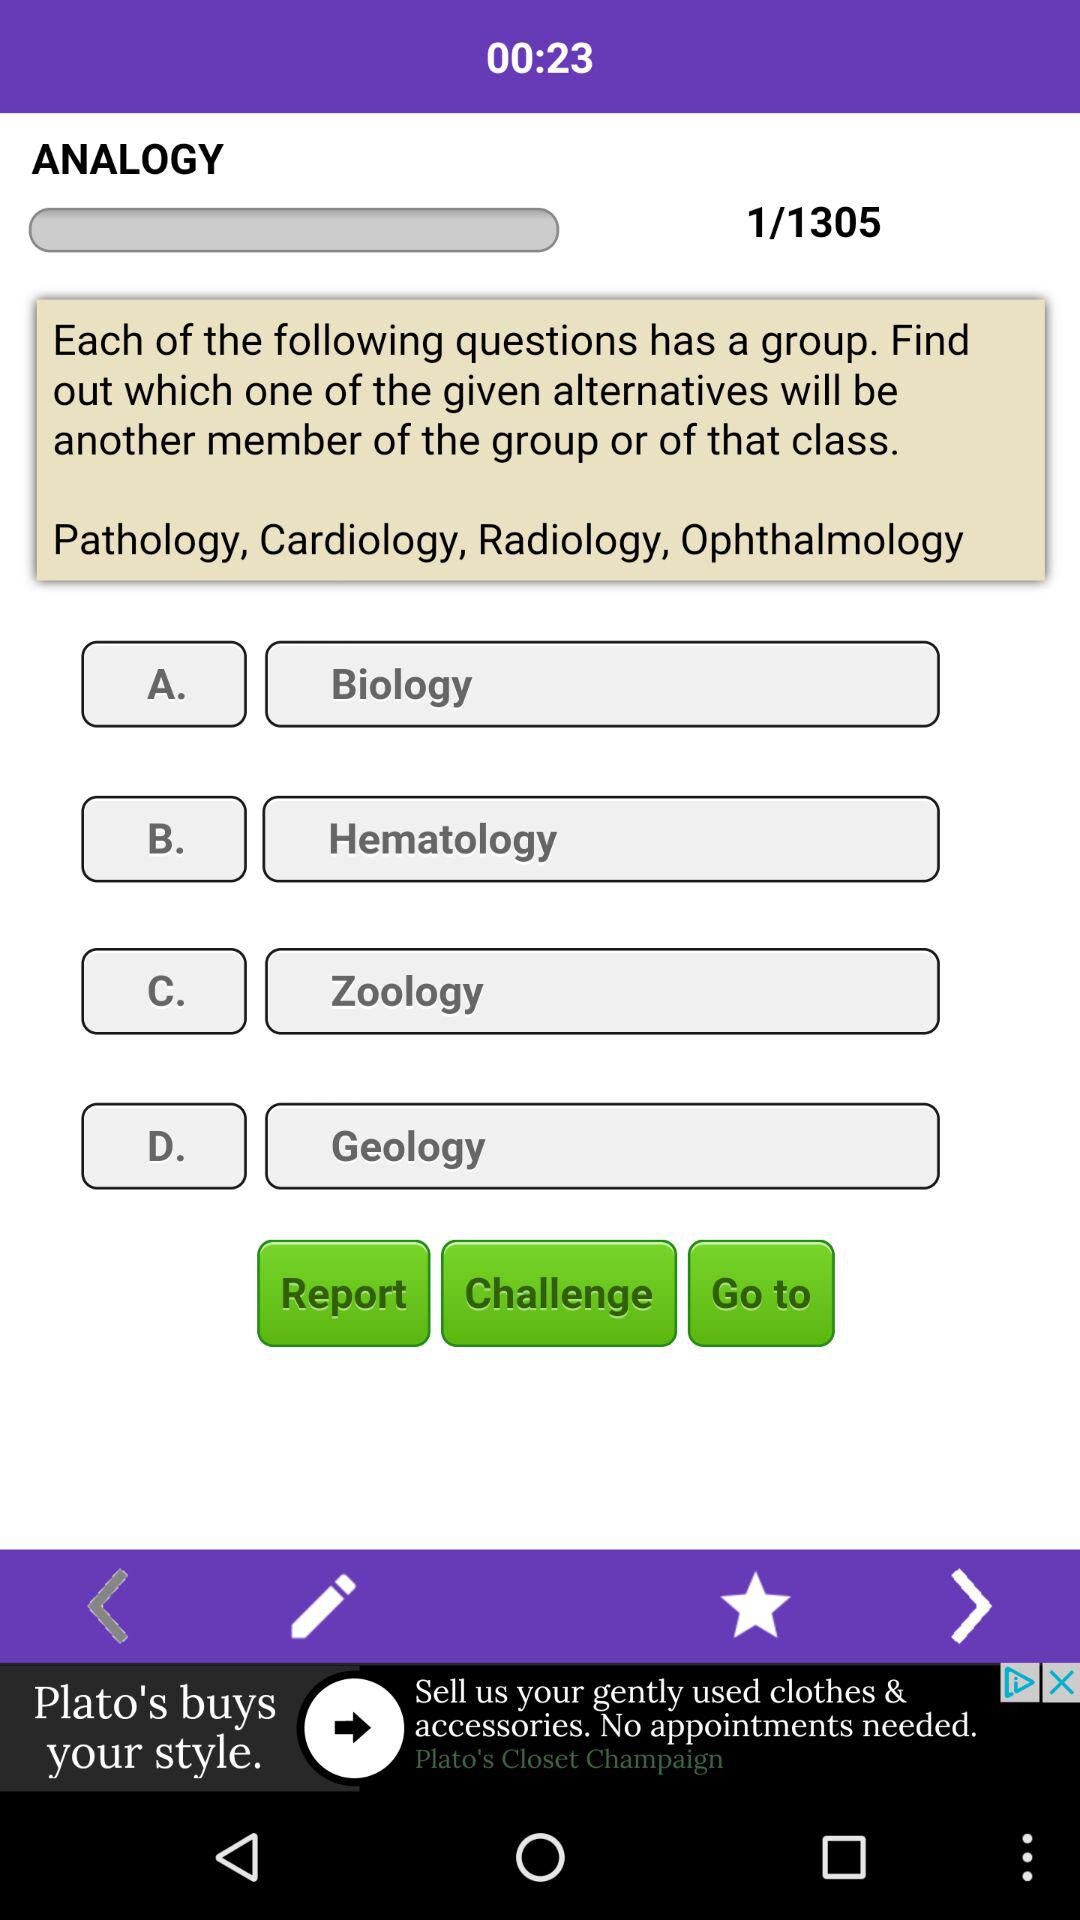How many pages in total are there? There are 1305 pages. 